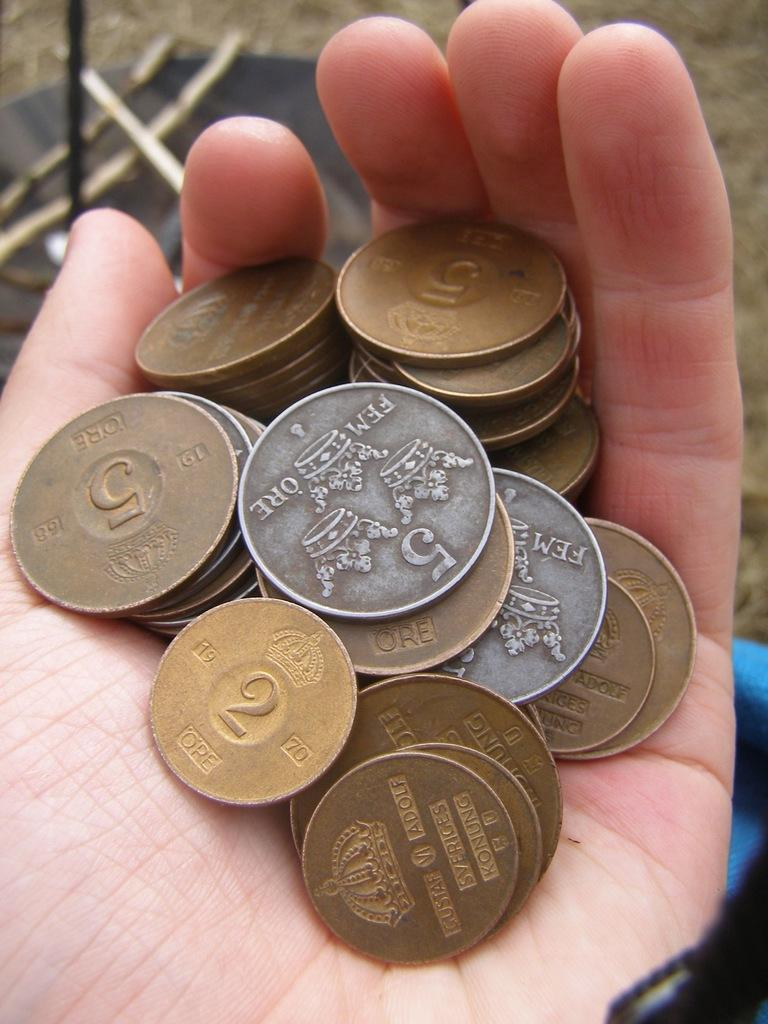What is the main subject of the image? The main subject of the image is a hand with coins. What can be seen in the background of the image? There is a path visible in the background of the image, and objects are placed on the path. Can you describe the haircut of the person in the image? There is no person visible in the image, only a hand with coins and a background with a path and objects. Is there a lake visible in the image? No, there is no lake present in the image. 